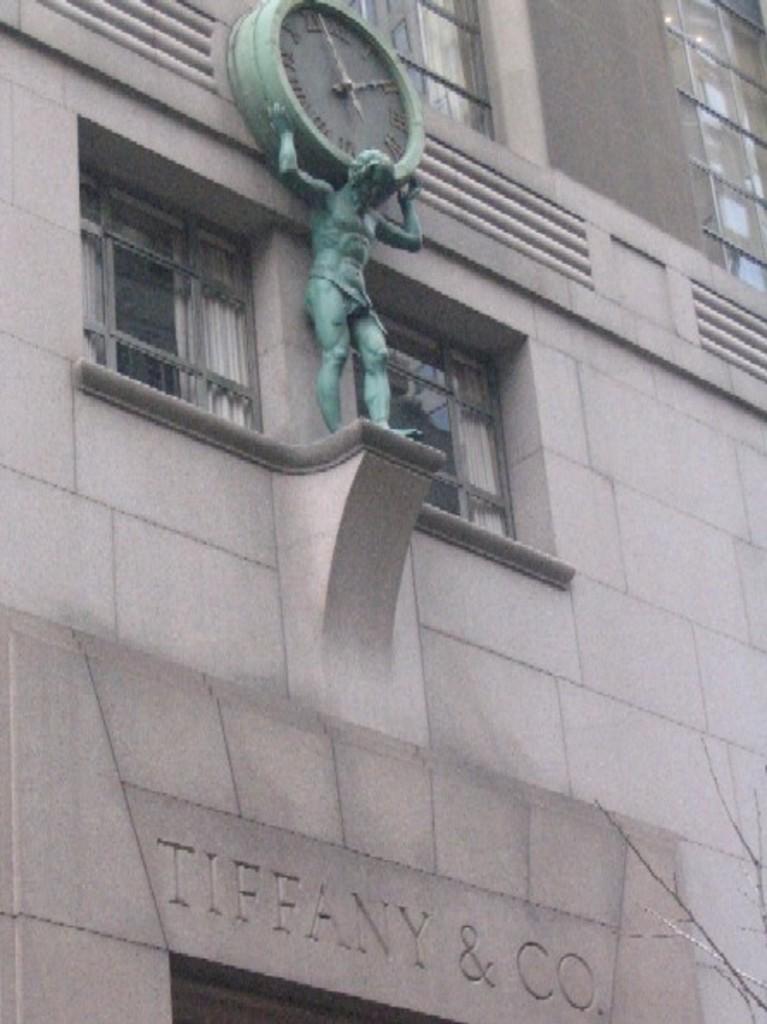How would you summarize this image in a sentence or two? In this picture we can see a building. There is a sculpture on this building. A man is holding a clock(sculpture). 